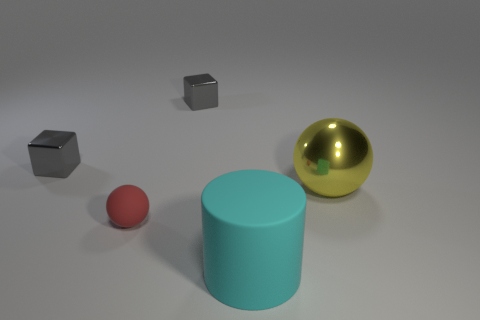Are there more small red metallic spheres than large cyan cylinders?
Offer a terse response. No. There is a yellow ball that is the same size as the cyan matte thing; what is its material?
Keep it short and to the point. Metal. There is a object that is to the right of the cyan rubber cylinder; does it have the same size as the big cylinder?
Give a very brief answer. Yes. How many spheres are small red matte objects or large cyan objects?
Your answer should be compact. 1. There is a gray cube on the right side of the tiny sphere; what is its material?
Make the answer very short. Metal. Is the number of small gray cylinders less than the number of big shiny things?
Provide a succinct answer. Yes. What size is the thing that is both behind the cyan matte cylinder and in front of the big yellow sphere?
Your answer should be compact. Small. There is a shiny thing that is right of the gray metallic thing that is on the right side of the rubber object behind the large rubber object; what size is it?
Your answer should be very brief. Large. How many other things are the same color as the matte sphere?
Your answer should be very brief. 0. How many things are either shiny objects or large matte things?
Provide a short and direct response. 4. 